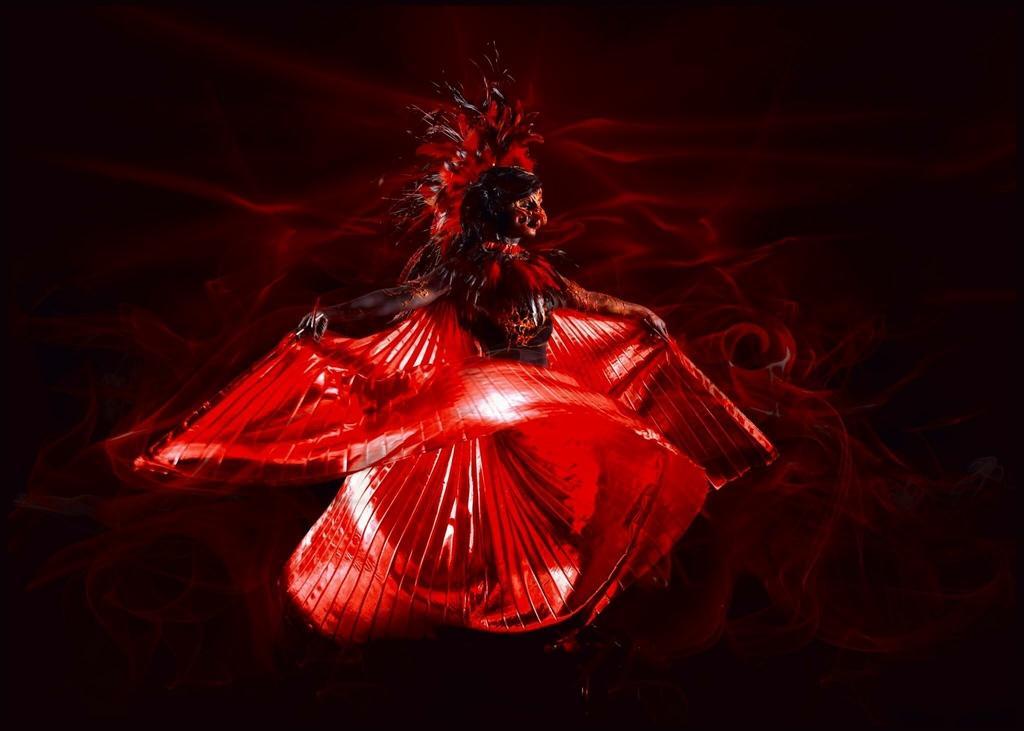Describe this image in one or two sentences. In this picture we can see a painting of a dancing woman in red. 